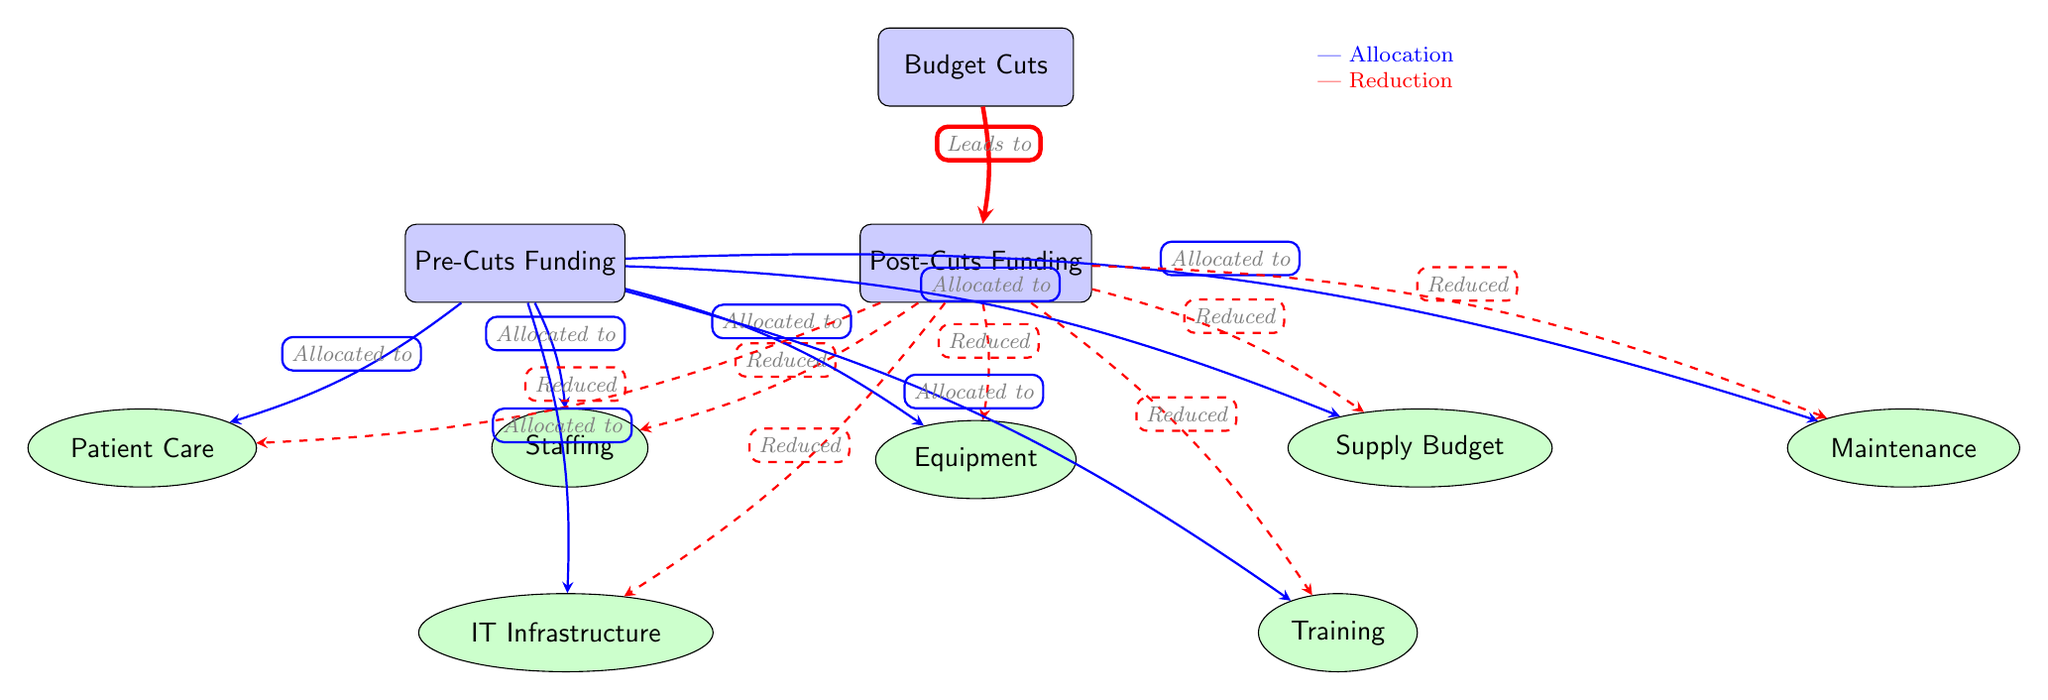What is the main cause leading to post-cuts funding? The diagram clearly indicates that "Budget Cuts" leads to "Post-Cuts Funding", making it evident that budget cuts are the main cause of reduced funding.
Answer: Budget Cuts How many main nodes are in the diagram? The diagram has three main nodes, which are "Budget Cuts", "Pre-Cuts Funding", and "Post-Cuts Funding".
Answer: Three What does the dashed arrow from post-cuts funding to staffing indicate? The dashed arrow signifies a reduction in funding for "Staffing" after the budget cuts, suggesting that resources in this area have been decreased.
Answer: Reduced Which area has a direct allocation from pre-cuts funding other than staffing? Looking at the connections, the areas directly allocated from pre-cuts funding besides staffing include "Equipment", "Supply Budget", "Patient Care", "Maintenance", "IT Infrastructure", and "Training". Therefore, one example is "Equipment".
Answer: Equipment How many areas are affected by the budget cuts according to the diagram? The areas affected by budget cuts include "Staffing", "Equipment", "Supply Budget", "Patient Care", "Maintenance", "IT Infrastructure", and "Training". Counting these, there are seven affected areas.
Answer: Seven What color denotes allocation in the diagram? From the legend provided in the diagram, blue represents allocation, indicating that the arrows leading from pre-cuts funding towards the areas are colored blue.
Answer: Blue Which connections in the diagram indicate resource reduction? The dashed red arrows denote resource reductions in all areas from post-cuts funding, clearly marking these connections as reductions.
Answer: Dashed Red Arrows What type of node is "Post-Cuts Funding"? "Post-Cuts Funding" is classified as a main node, as indicated by the diagram's styling with a rectangle shape for main nodes.
Answer: Main Node 